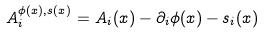<formula> <loc_0><loc_0><loc_500><loc_500>A _ { i } ^ { \phi ( x ) , s ( x ) } = A _ { i } ( x ) - \partial _ { i } \phi ( x ) - s _ { i } ( x )</formula> 